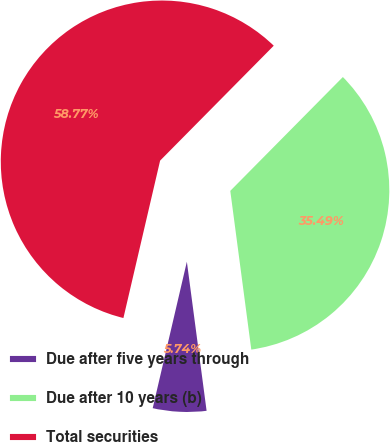<chart> <loc_0><loc_0><loc_500><loc_500><pie_chart><fcel>Due after five years through<fcel>Due after 10 years (b)<fcel>Total securities<nl><fcel>5.74%<fcel>35.49%<fcel>58.76%<nl></chart> 